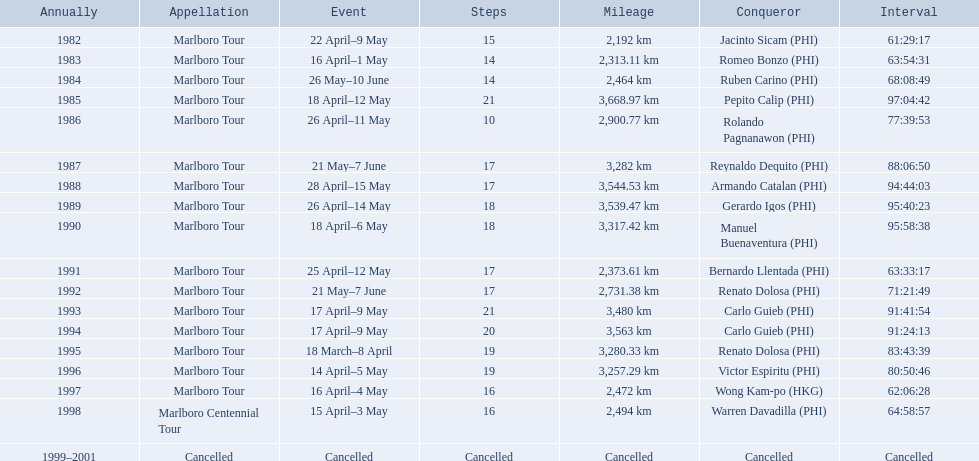What were the tour names during le tour de filipinas? Marlboro Tour, Marlboro Tour, Marlboro Tour, Marlboro Tour, Marlboro Tour, Marlboro Tour, Marlboro Tour, Marlboro Tour, Marlboro Tour, Marlboro Tour, Marlboro Tour, Marlboro Tour, Marlboro Tour, Marlboro Tour, Marlboro Tour, Marlboro Tour, Marlboro Centennial Tour, Cancelled. What were the recorded distances for each marlboro tour? 2,192 km, 2,313.11 km, 2,464 km, 3,668.97 km, 2,900.77 km, 3,282 km, 3,544.53 km, 3,539.47 km, 3,317.42 km, 2,373.61 km, 2,731.38 km, 3,480 km, 3,563 km, 3,280.33 km, 3,257.29 km, 2,472 km. And of those distances, which was the longest? 3,668.97 km. 